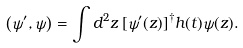<formula> <loc_0><loc_0><loc_500><loc_500>\left ( \psi ^ { \prime } , \psi \right ) = \int d ^ { 2 } z \, [ \psi ^ { \prime } ( z ) ] ^ { \dagger } h ( t ) \psi ( z ) .</formula> 